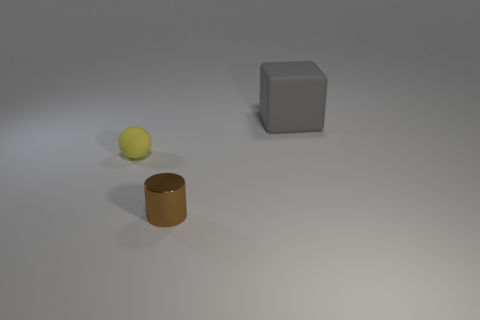Add 3 small rubber balls. How many objects exist? 6 Subtract all blocks. How many objects are left? 2 Subtract all large purple spheres. Subtract all matte balls. How many objects are left? 2 Add 3 yellow rubber spheres. How many yellow rubber spheres are left? 4 Add 2 yellow metallic cubes. How many yellow metallic cubes exist? 2 Subtract 0 brown cubes. How many objects are left? 3 Subtract 1 blocks. How many blocks are left? 0 Subtract all yellow cylinders. Subtract all cyan spheres. How many cylinders are left? 1 Subtract all blue balls. How many green cubes are left? 0 